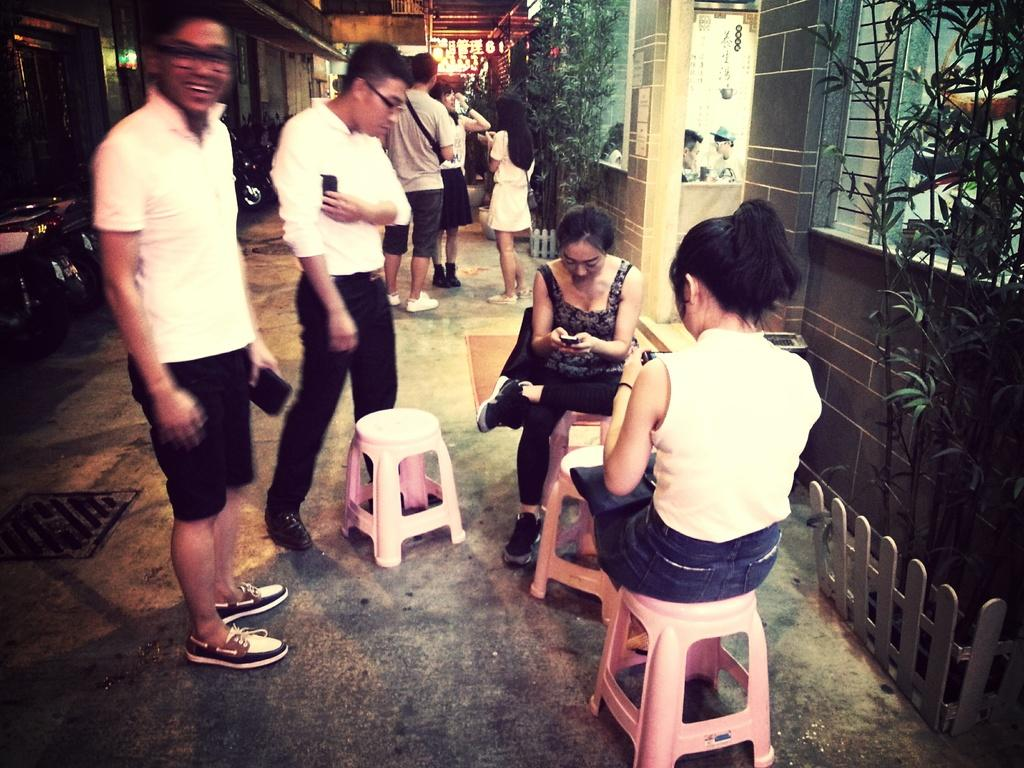How many girls are sitting in the image? There are two girls sitting on stools on the right side of the image. What are the girls doing in the image? The girls are sitting on stools. How many boys are standing in the image? There are two boys standing on the left side of the image. What type of flame can be seen behind the boys in the image? There is no flame present in the image. Is there a woman in the image? The provided facts do not mention a woman in the image. 